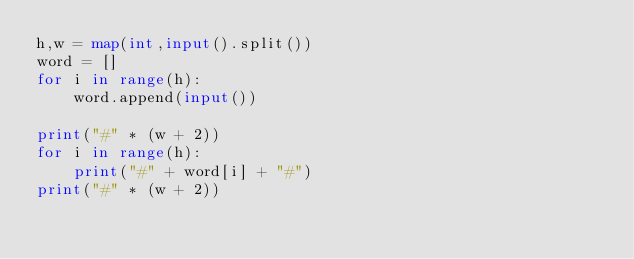<code> <loc_0><loc_0><loc_500><loc_500><_Python_>h,w = map(int,input().split())
word = []
for i in range(h):
    word.append(input())
 
print("#" * (w + 2))
for i in range(h):
    print("#" + word[i] + "#")
print("#" * (w + 2))</code> 